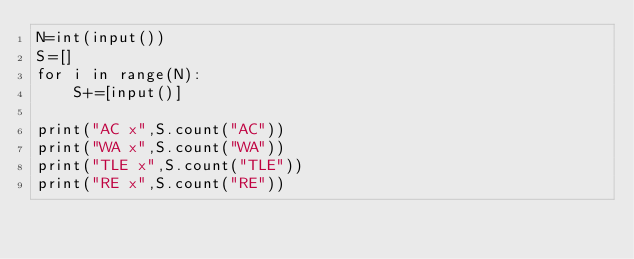<code> <loc_0><loc_0><loc_500><loc_500><_Python_>N=int(input())
S=[]
for i in range(N):
    S+=[input()]

print("AC x",S.count("AC"))
print("WA x",S.count("WA"))
print("TLE x",S.count("TLE"))
print("RE x",S.count("RE"))
</code> 